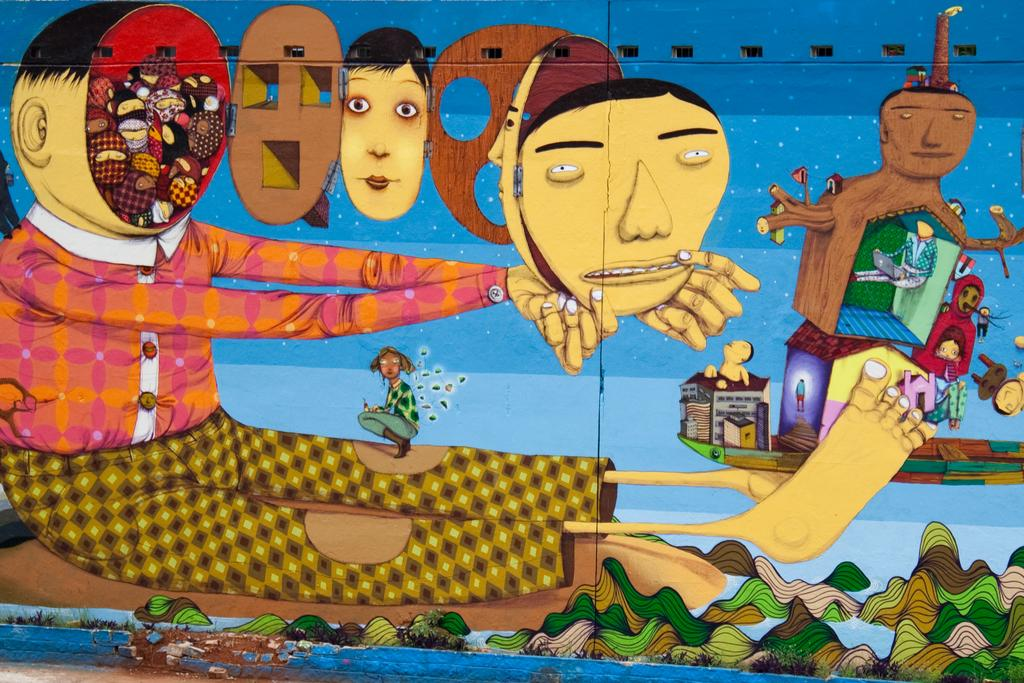What is present on the wall in the image? Cartoons are painted on the wall in the image. Can you describe the wall in the image? There is a wall in the image with cartoons painted on it. Where is the key located in the image? There is no key present in the image. Can you see a bridge in the image? There is no bridge present in the image. 